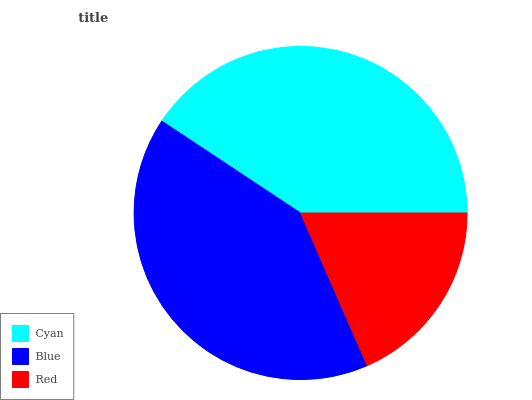Is Red the minimum?
Answer yes or no. Yes. Is Blue the maximum?
Answer yes or no. Yes. Is Blue the minimum?
Answer yes or no. No. Is Red the maximum?
Answer yes or no. No. Is Blue greater than Red?
Answer yes or no. Yes. Is Red less than Blue?
Answer yes or no. Yes. Is Red greater than Blue?
Answer yes or no. No. Is Blue less than Red?
Answer yes or no. No. Is Cyan the high median?
Answer yes or no. Yes. Is Cyan the low median?
Answer yes or no. Yes. Is Blue the high median?
Answer yes or no. No. Is Red the low median?
Answer yes or no. No. 